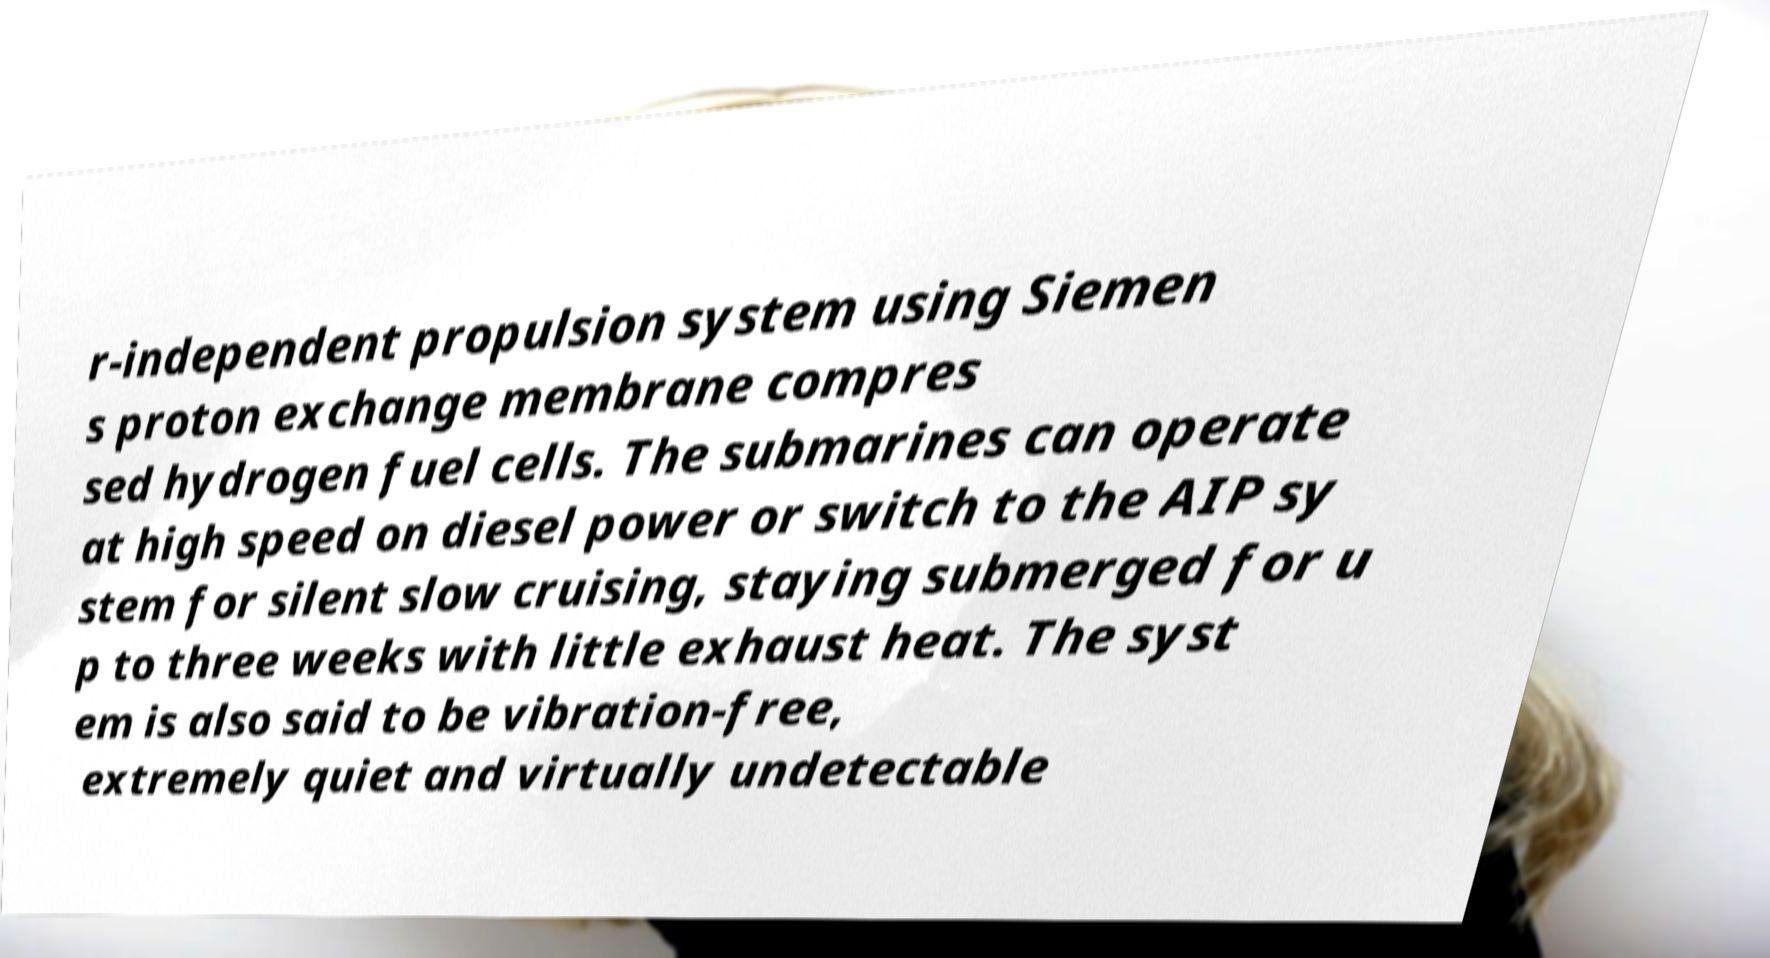Can you accurately transcribe the text from the provided image for me? r-independent propulsion system using Siemen s proton exchange membrane compres sed hydrogen fuel cells. The submarines can operate at high speed on diesel power or switch to the AIP sy stem for silent slow cruising, staying submerged for u p to three weeks with little exhaust heat. The syst em is also said to be vibration-free, extremely quiet and virtually undetectable 